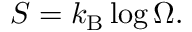<formula> <loc_0><loc_0><loc_500><loc_500>S = k _ { B } \log \Omega .</formula> 